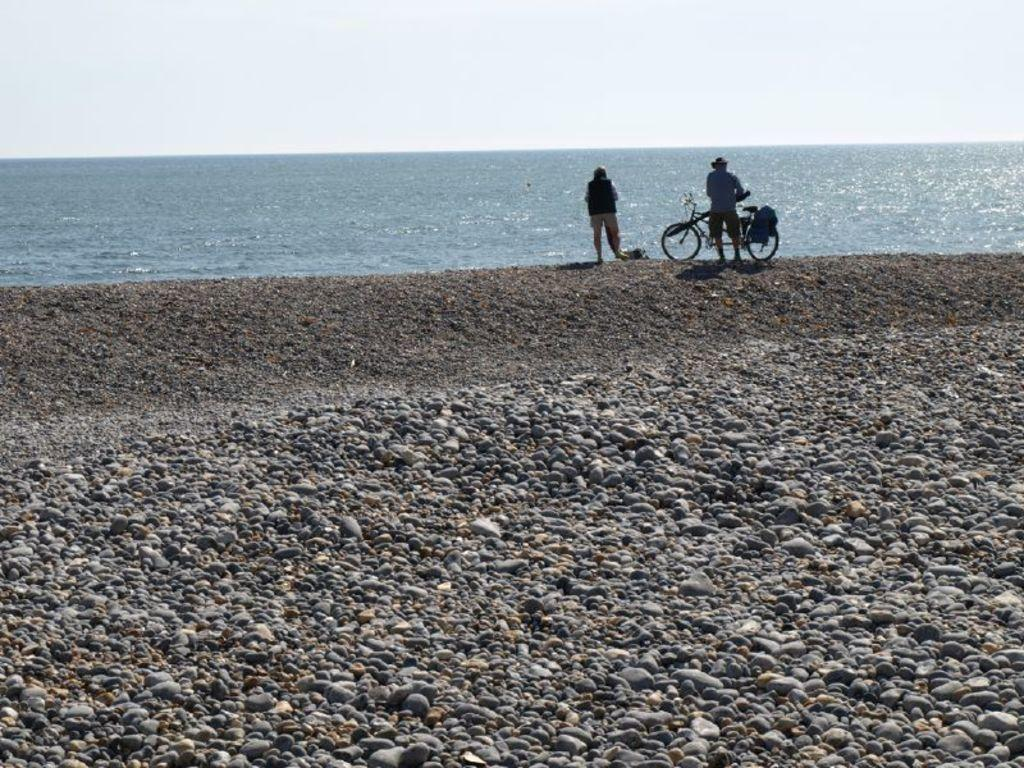How many people are in the image? There are two persons in the image. What object can be seen besides the people? There is a bicycle in the image. What type of natural feature is visible behind the persons? There is water visible behind the persons. What is visible at the top of the image? The sky is visible at the top of the image. What type of surface is in the foreground of the image? There are stones in the foreground of the image. What type of cream is being used to paint the crib in the image? There is no crib or cream present in the image. What role does the father play in the image? There is no mention of a father or any specific roles in the image. 